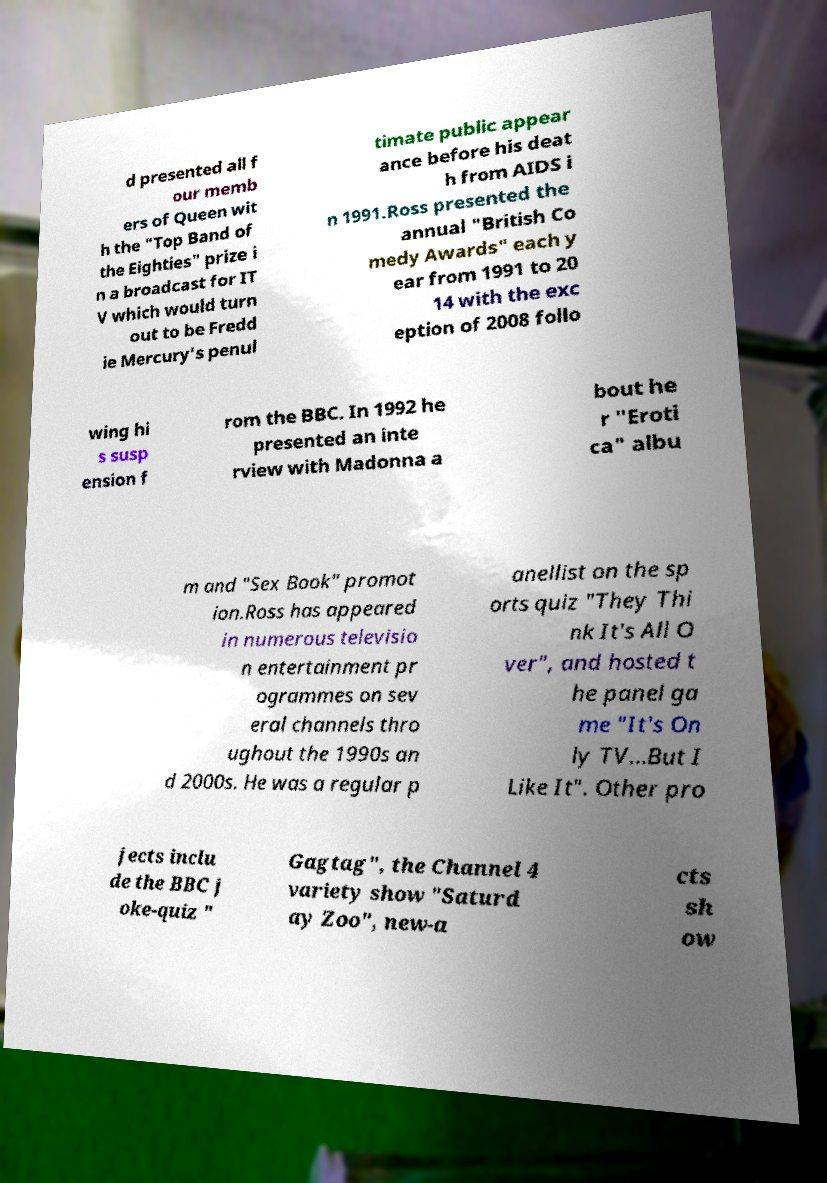Could you assist in decoding the text presented in this image and type it out clearly? d presented all f our memb ers of Queen wit h the "Top Band of the Eighties" prize i n a broadcast for IT V which would turn out to be Fredd ie Mercury's penul timate public appear ance before his deat h from AIDS i n 1991.Ross presented the annual "British Co medy Awards" each y ear from 1991 to 20 14 with the exc eption of 2008 follo wing hi s susp ension f rom the BBC. In 1992 he presented an inte rview with Madonna a bout he r "Eroti ca" albu m and "Sex Book" promot ion.Ross has appeared in numerous televisio n entertainment pr ogrammes on sev eral channels thro ughout the 1990s an d 2000s. He was a regular p anellist on the sp orts quiz "They Thi nk It's All O ver", and hosted t he panel ga me "It's On ly TV...But I Like It". Other pro jects inclu de the BBC j oke-quiz " Gagtag", the Channel 4 variety show "Saturd ay Zoo", new-a cts sh ow 